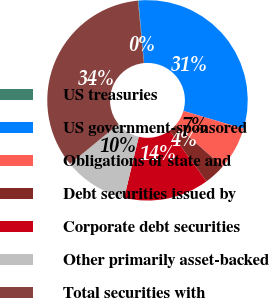Convert chart. <chart><loc_0><loc_0><loc_500><loc_500><pie_chart><fcel>US treasuries<fcel>US government-sponsored<fcel>Obligations of state and<fcel>Debt securities issued by<fcel>Corporate debt securities<fcel>Other primarily asset-backed<fcel>Total securities with<nl><fcel>0.09%<fcel>31.0%<fcel>6.92%<fcel>3.5%<fcel>13.75%<fcel>10.33%<fcel>34.41%<nl></chart> 